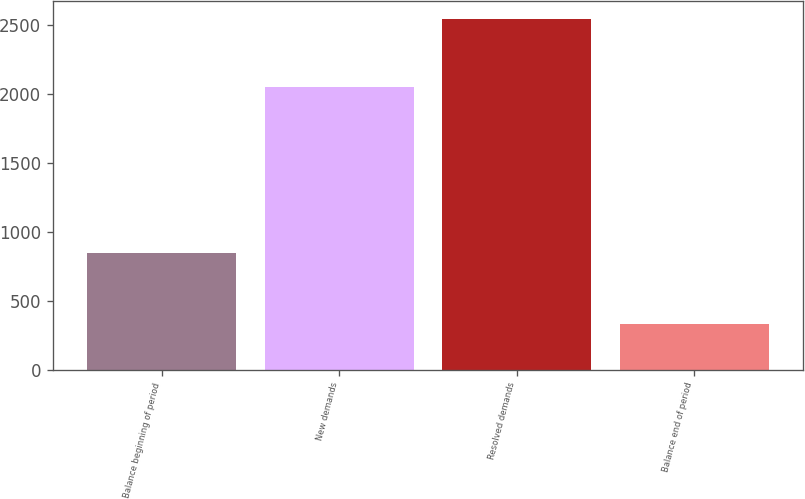<chart> <loc_0><loc_0><loc_500><loc_500><bar_chart><fcel>Balance beginning of period<fcel>New demands<fcel>Resolved demands<fcel>Balance end of period<nl><fcel>845<fcel>2050<fcel>2546<fcel>328<nl></chart> 